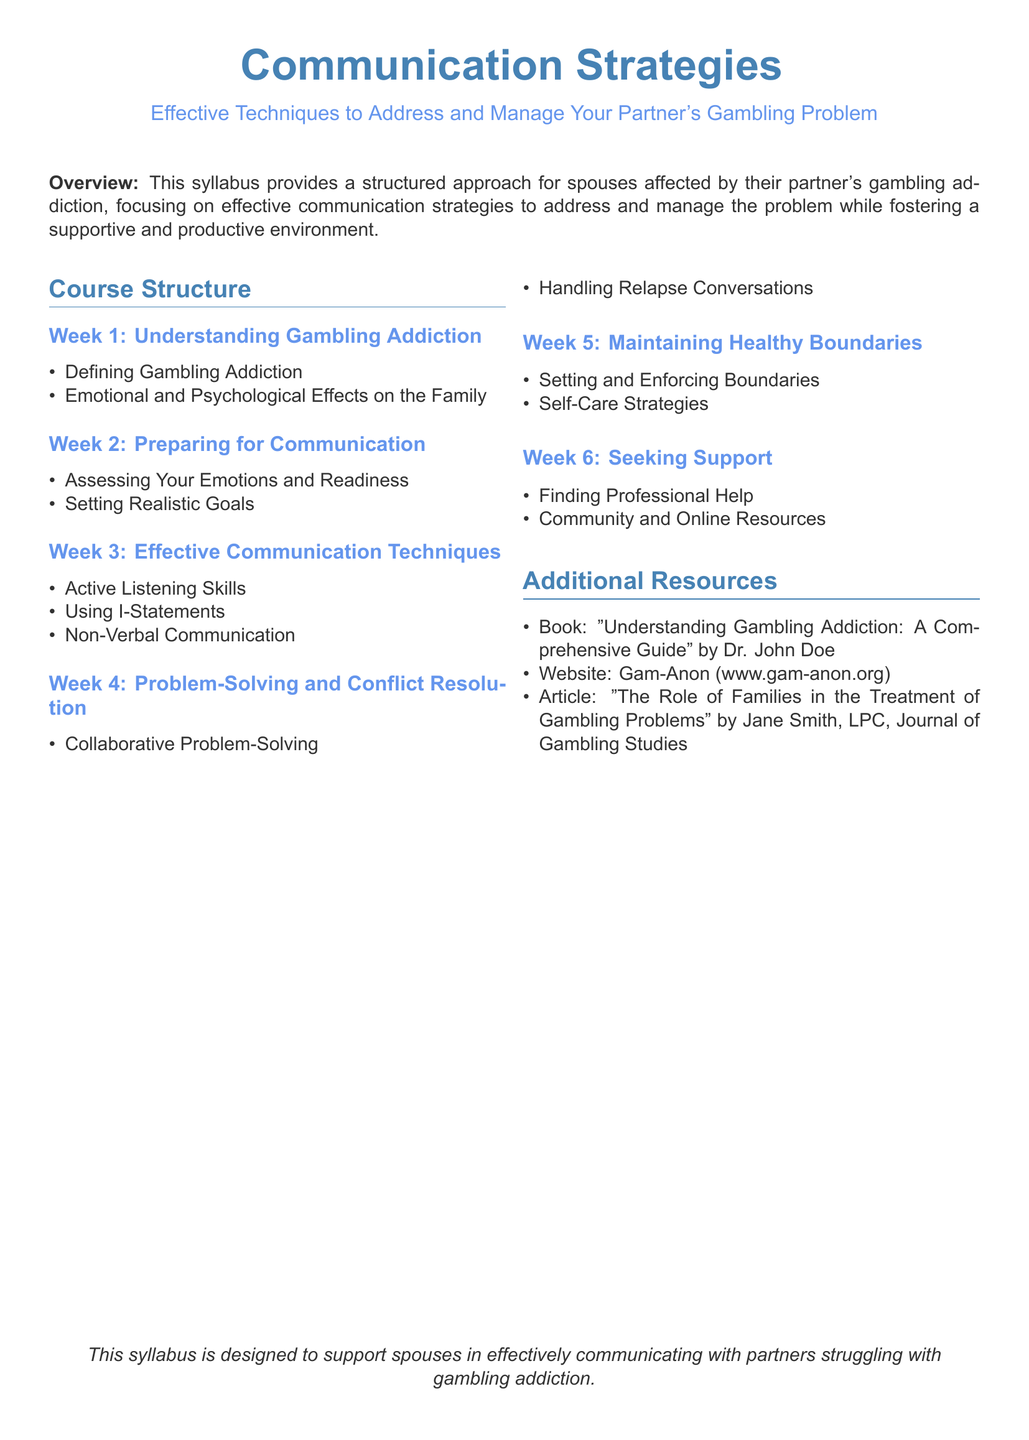What is the focus of the syllabus? The syllabus provides a structured approach for spouses affected by their partner's gambling addiction, focusing on effective communication strategies.
Answer: Effective communication strategies What is discussed in Week 1? Week 1 covers topics related to gambling addiction as well as its emotional and psychological effects on the family.
Answer: Understanding Gambling Addiction What are the two aspects covered in Week 5? Week 5 focuses on setting boundaries and self-care strategies, essential for managing the relationship effectively.
Answer: Setting and Enforcing Boundaries, Self-Care Strategies What is one of the resources mentioned? The syllabus lists additional resources like a book, a website, and an article to support the spouse.
Answer: Book: "Understanding Gambling Addiction: A Comprehensive Guide" How many weeks is the course structured into? The syllabus outlines a course structure consisting of six weeks, each focusing on specific topics related to gambling addiction and communication.
Answer: Six weeks What is a technique emphasized in Week 3? Active listening skills are highlighted as an important technique to help facilitate effective communication with a partner dealing with gambling issues.
Answer: Active Listening Skills What is the primary audience for this syllabus? The syllabus is designed specifically for spouses affected by their partner's gambling addiction, aiming to help them communicate effectively.
Answer: Spouses What is one goal of the course? The course aims to equip spouses with effective communication techniques that will help in managing the challenges posed by gambling addiction.
Answer: Manage gambling addiction What kind of support is discussed in Week 6? The syllabus emphasizes the importance of seeking professional help and finding community and online resources for support in dealing with gambling addiction.
Answer: Seeking Support 